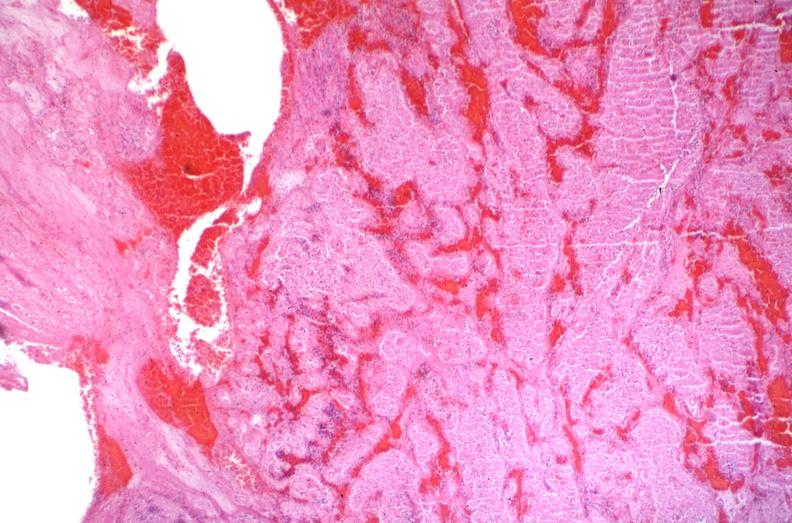s cardiovascular present?
Answer the question using a single word or phrase. Yes 